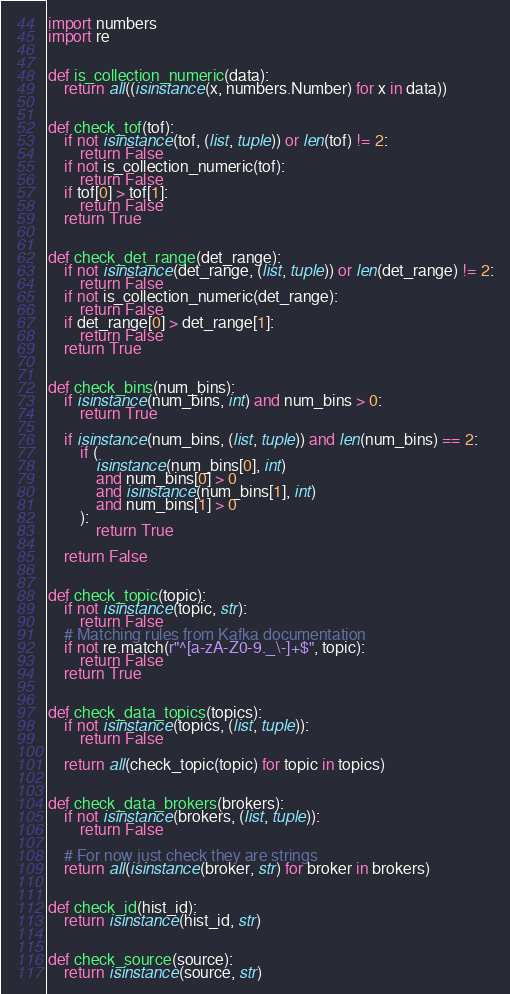Convert code to text. <code><loc_0><loc_0><loc_500><loc_500><_Python_>import numbers
import re


def is_collection_numeric(data):
    return all((isinstance(x, numbers.Number) for x in data))


def check_tof(tof):
    if not isinstance(tof, (list, tuple)) or len(tof) != 2:
        return False
    if not is_collection_numeric(tof):
        return False
    if tof[0] > tof[1]:
        return False
    return True


def check_det_range(det_range):
    if not isinstance(det_range, (list, tuple)) or len(det_range) != 2:
        return False
    if not is_collection_numeric(det_range):
        return False
    if det_range[0] > det_range[1]:
        return False
    return True


def check_bins(num_bins):
    if isinstance(num_bins, int) and num_bins > 0:
        return True

    if isinstance(num_bins, (list, tuple)) and len(num_bins) == 2:
        if (
            isinstance(num_bins[0], int)
            and num_bins[0] > 0
            and isinstance(num_bins[1], int)
            and num_bins[1] > 0
        ):
            return True

    return False


def check_topic(topic):
    if not isinstance(topic, str):
        return False
    # Matching rules from Kafka documentation
    if not re.match(r"^[a-zA-Z0-9._\-]+$", topic):
        return False
    return True


def check_data_topics(topics):
    if not isinstance(topics, (list, tuple)):
        return False

    return all(check_topic(topic) for topic in topics)


def check_data_brokers(brokers):
    if not isinstance(brokers, (list, tuple)):
        return False

    # For now just check they are strings
    return all(isinstance(broker, str) for broker in brokers)


def check_id(hist_id):
    return isinstance(hist_id, str)


def check_source(source):
    return isinstance(source, str)
</code> 